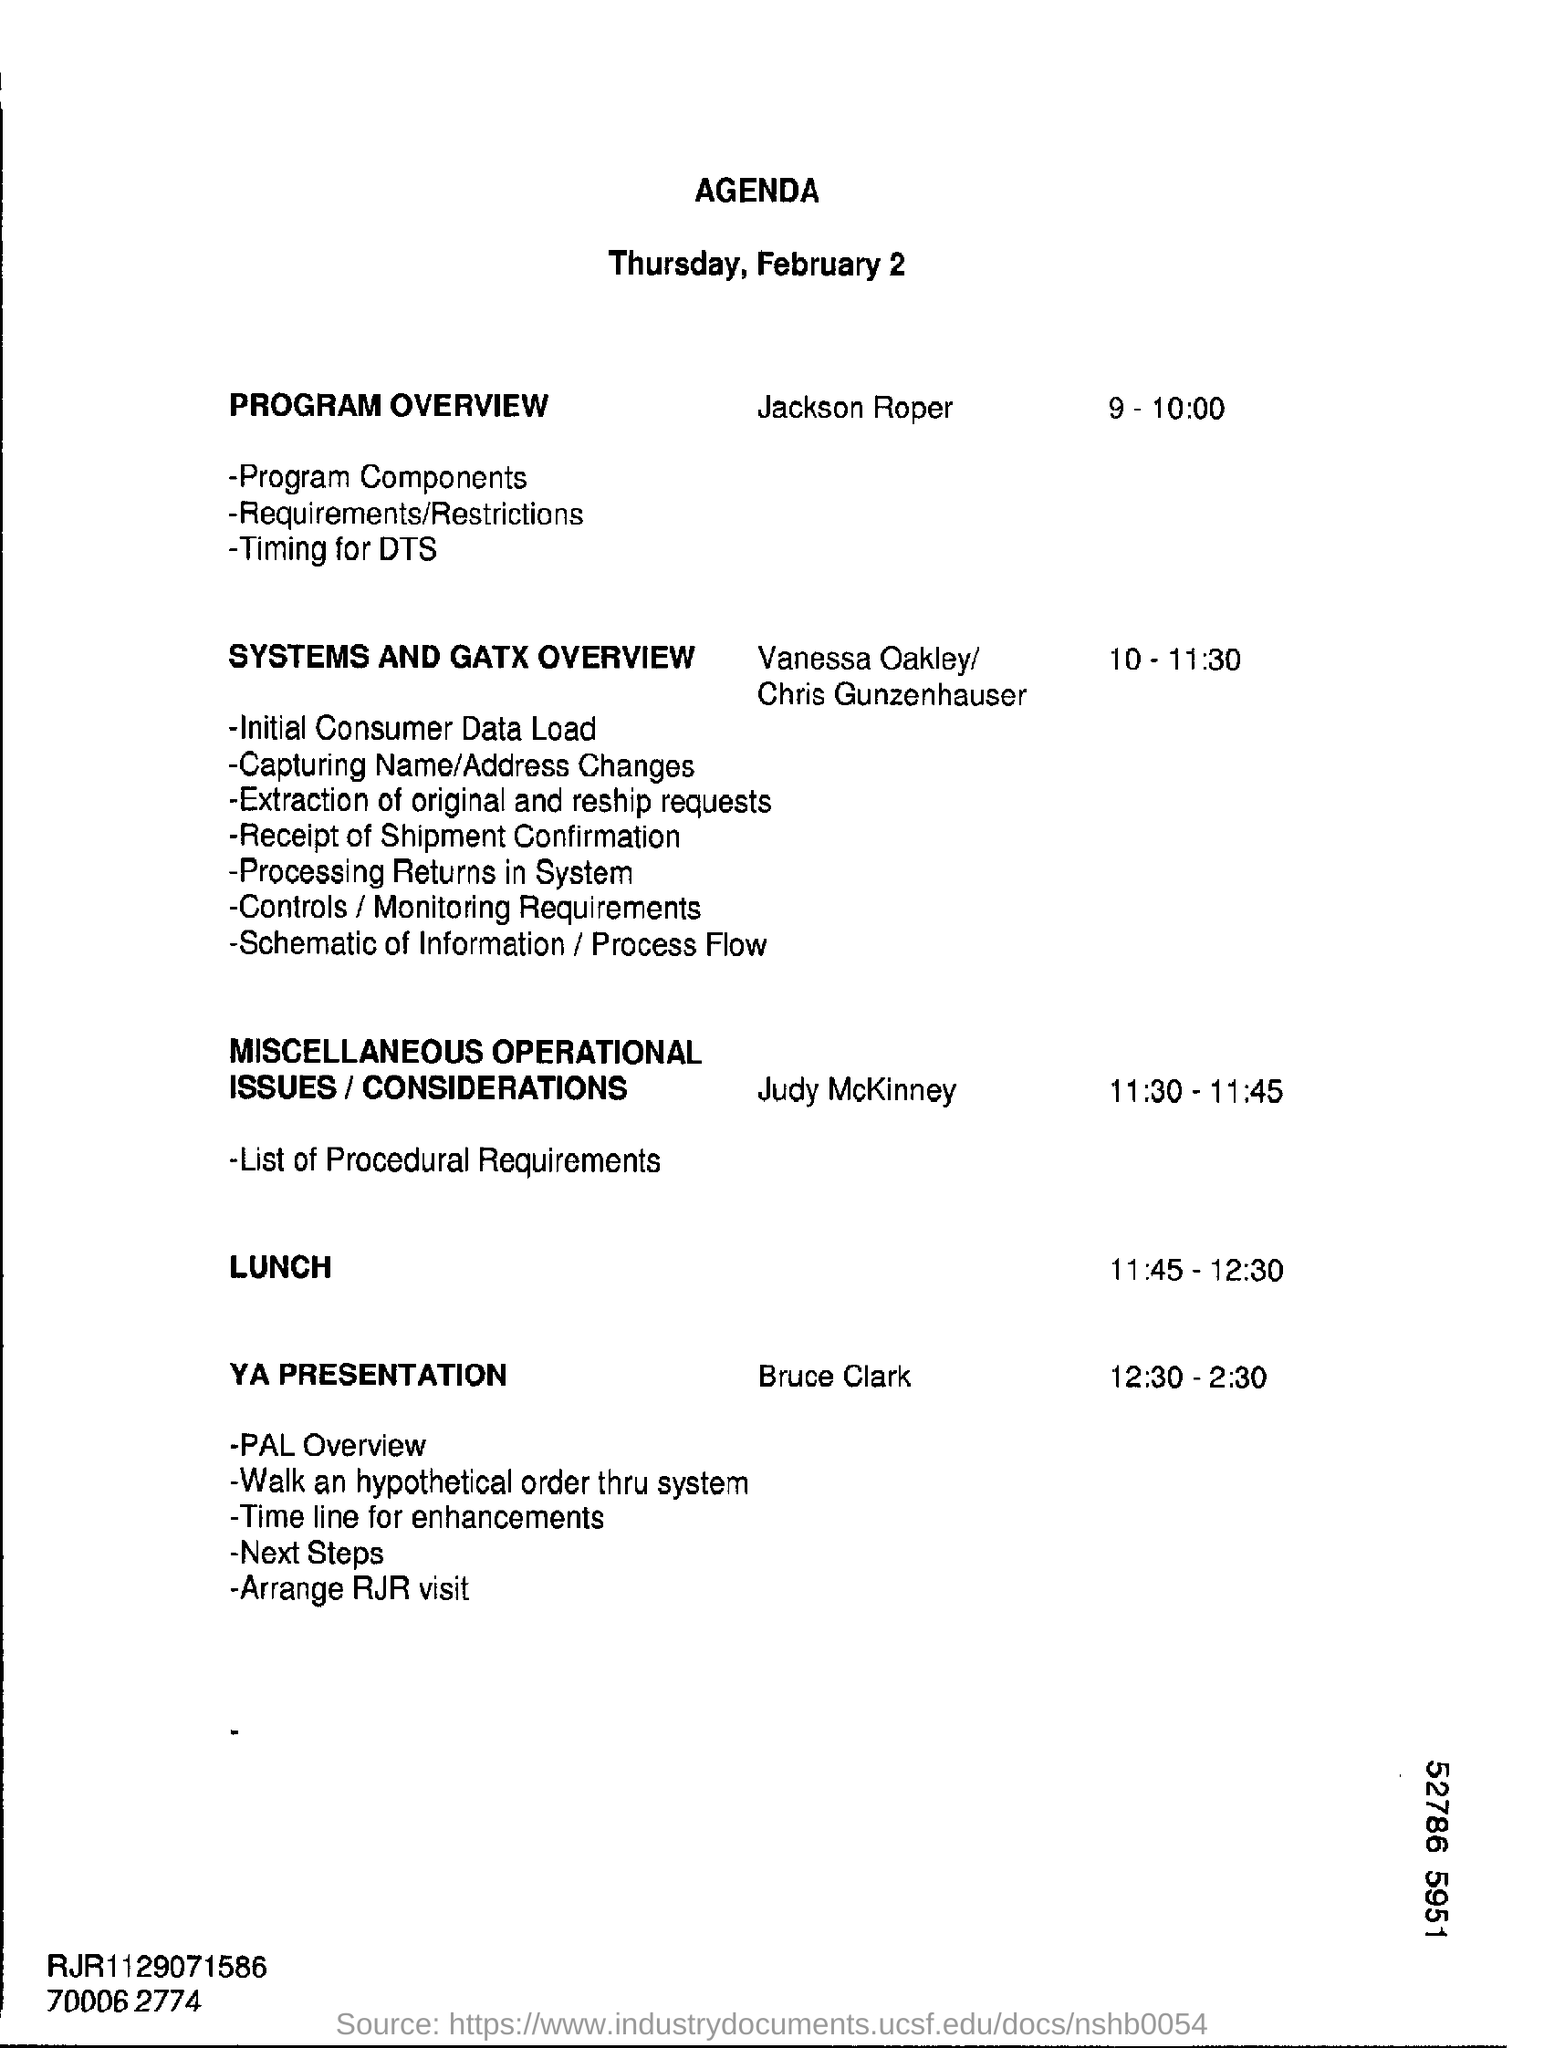Highlight a few significant elements in this photo. The lunch time is from 11:45 to 12:30. The date mentioned at the beginning of the document is Thursday, February 2. 